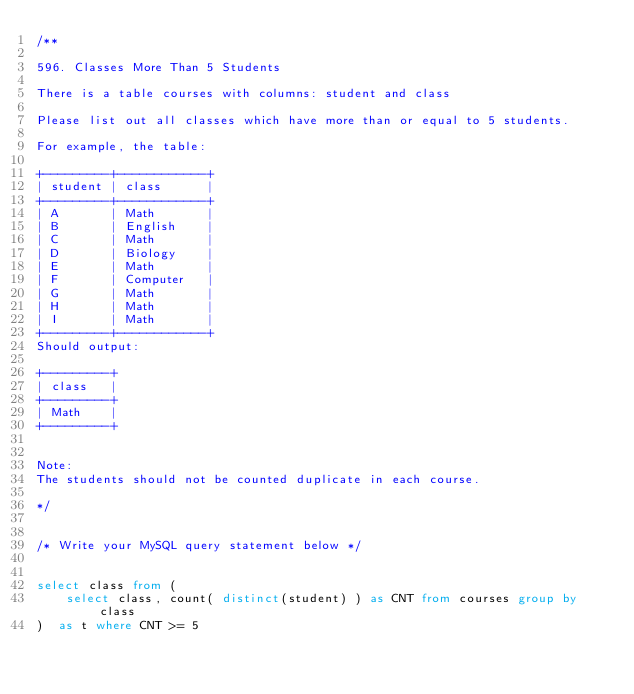Convert code to text. <code><loc_0><loc_0><loc_500><loc_500><_SQL_>/**

596. Classes More Than 5 Students

There is a table courses with columns: student and class

Please list out all classes which have more than or equal to 5 students.

For example, the table:

+---------+------------+
| student | class      |
+---------+------------+
| A       | Math       |
| B       | English    |
| C       | Math       |
| D       | Biology    |
| E       | Math       |
| F       | Computer   |
| G       | Math       |
| H       | Math       |
| I       | Math       |
+---------+------------+
Should output:

+---------+
| class   |
+---------+
| Math    |
+---------+
 

Note:
The students should not be counted duplicate in each course.

*/


/* Write your MySQL query statement below */


select class from (
    select class, count( distinct(student) ) as CNT from courses group by class
)  as t where CNT >= 5

</code> 